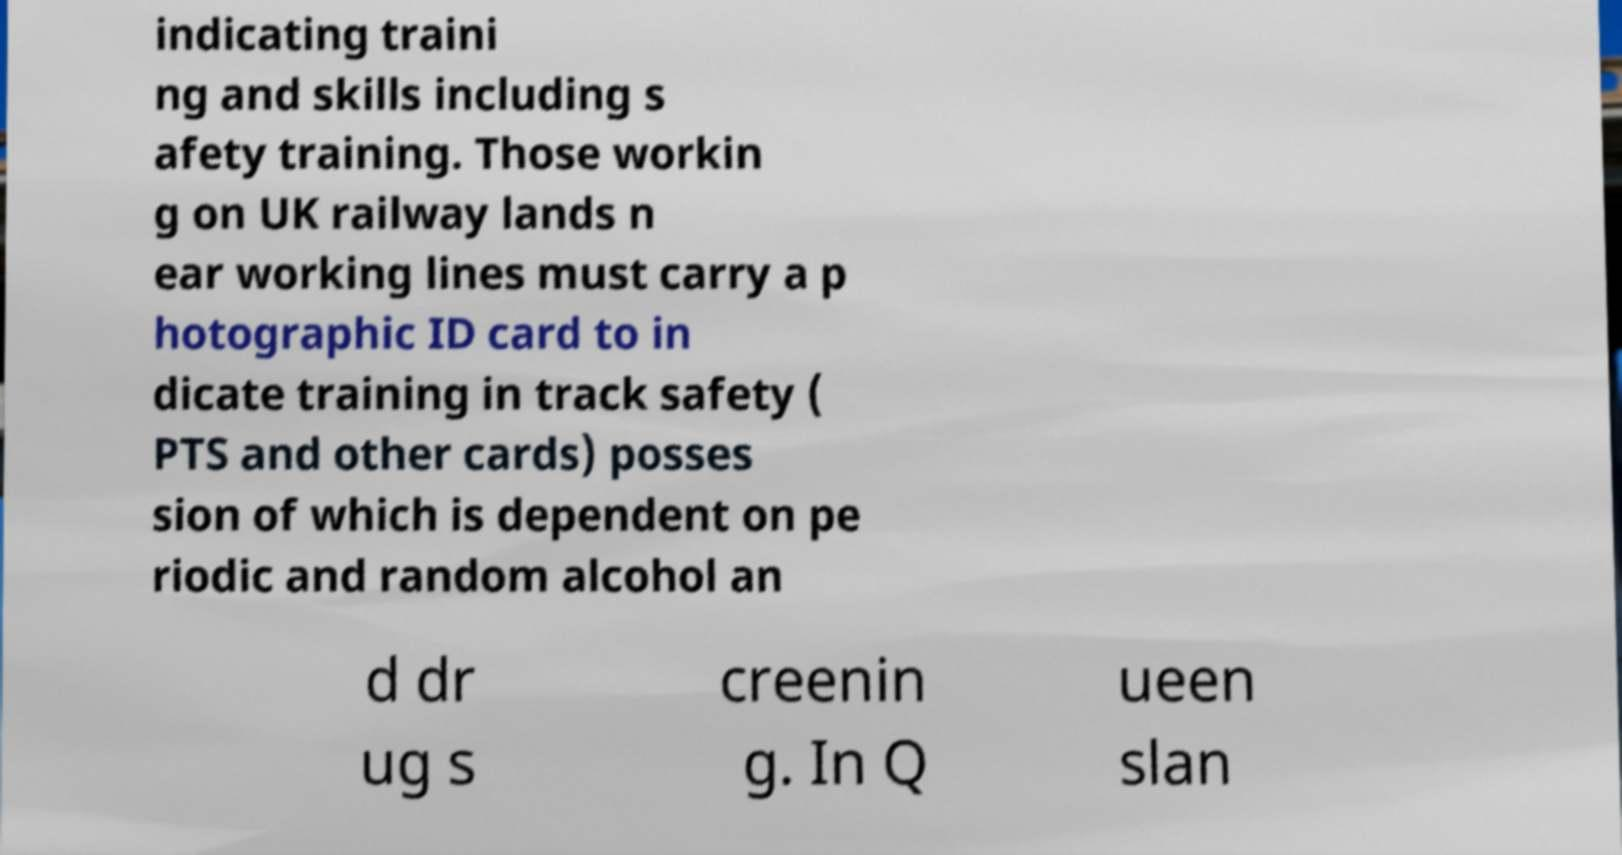For documentation purposes, I need the text within this image transcribed. Could you provide that? indicating traini ng and skills including s afety training. Those workin g on UK railway lands n ear working lines must carry a p hotographic ID card to in dicate training in track safety ( PTS and other cards) posses sion of which is dependent on pe riodic and random alcohol an d dr ug s creenin g. In Q ueen slan 